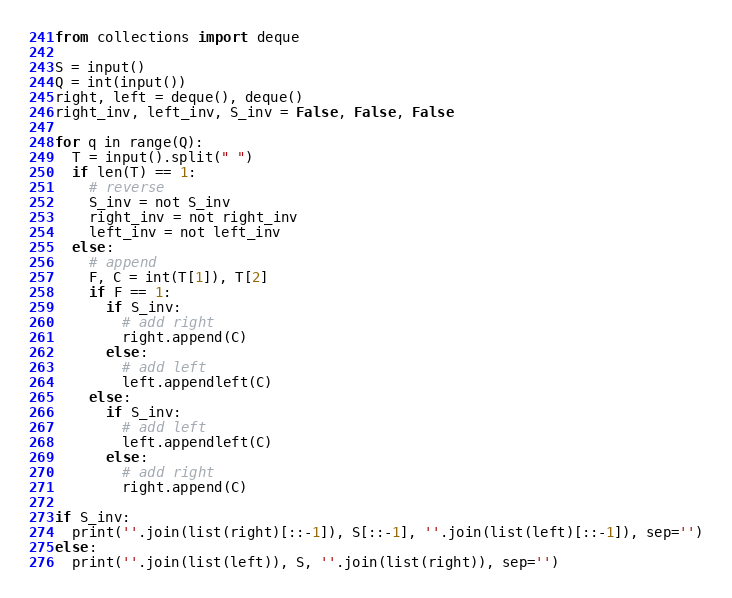Convert code to text. <code><loc_0><loc_0><loc_500><loc_500><_Python_>from collections import deque

S = input()
Q = int(input())
right, left = deque(), deque()
right_inv, left_inv, S_inv = False, False, False

for q in range(Q):
  T = input().split(" ")
  if len(T) == 1:
    # reverse
    S_inv = not S_inv
    right_inv = not right_inv
    left_inv = not left_inv
  else:
    # append
    F, C = int(T[1]), T[2]
    if F == 1:
      if S_inv:
        # add right
        right.append(C)
      else:
        # add left
        left.appendleft(C)
    else:
      if S_inv:
        # add left
        left.appendleft(C)
      else:
        # add right
        right.append(C)

if S_inv:
  print(''.join(list(right)[::-1]), S[::-1], ''.join(list(left)[::-1]), sep='')
else:
  print(''.join(list(left)), S, ''.join(list(right)), sep='')</code> 